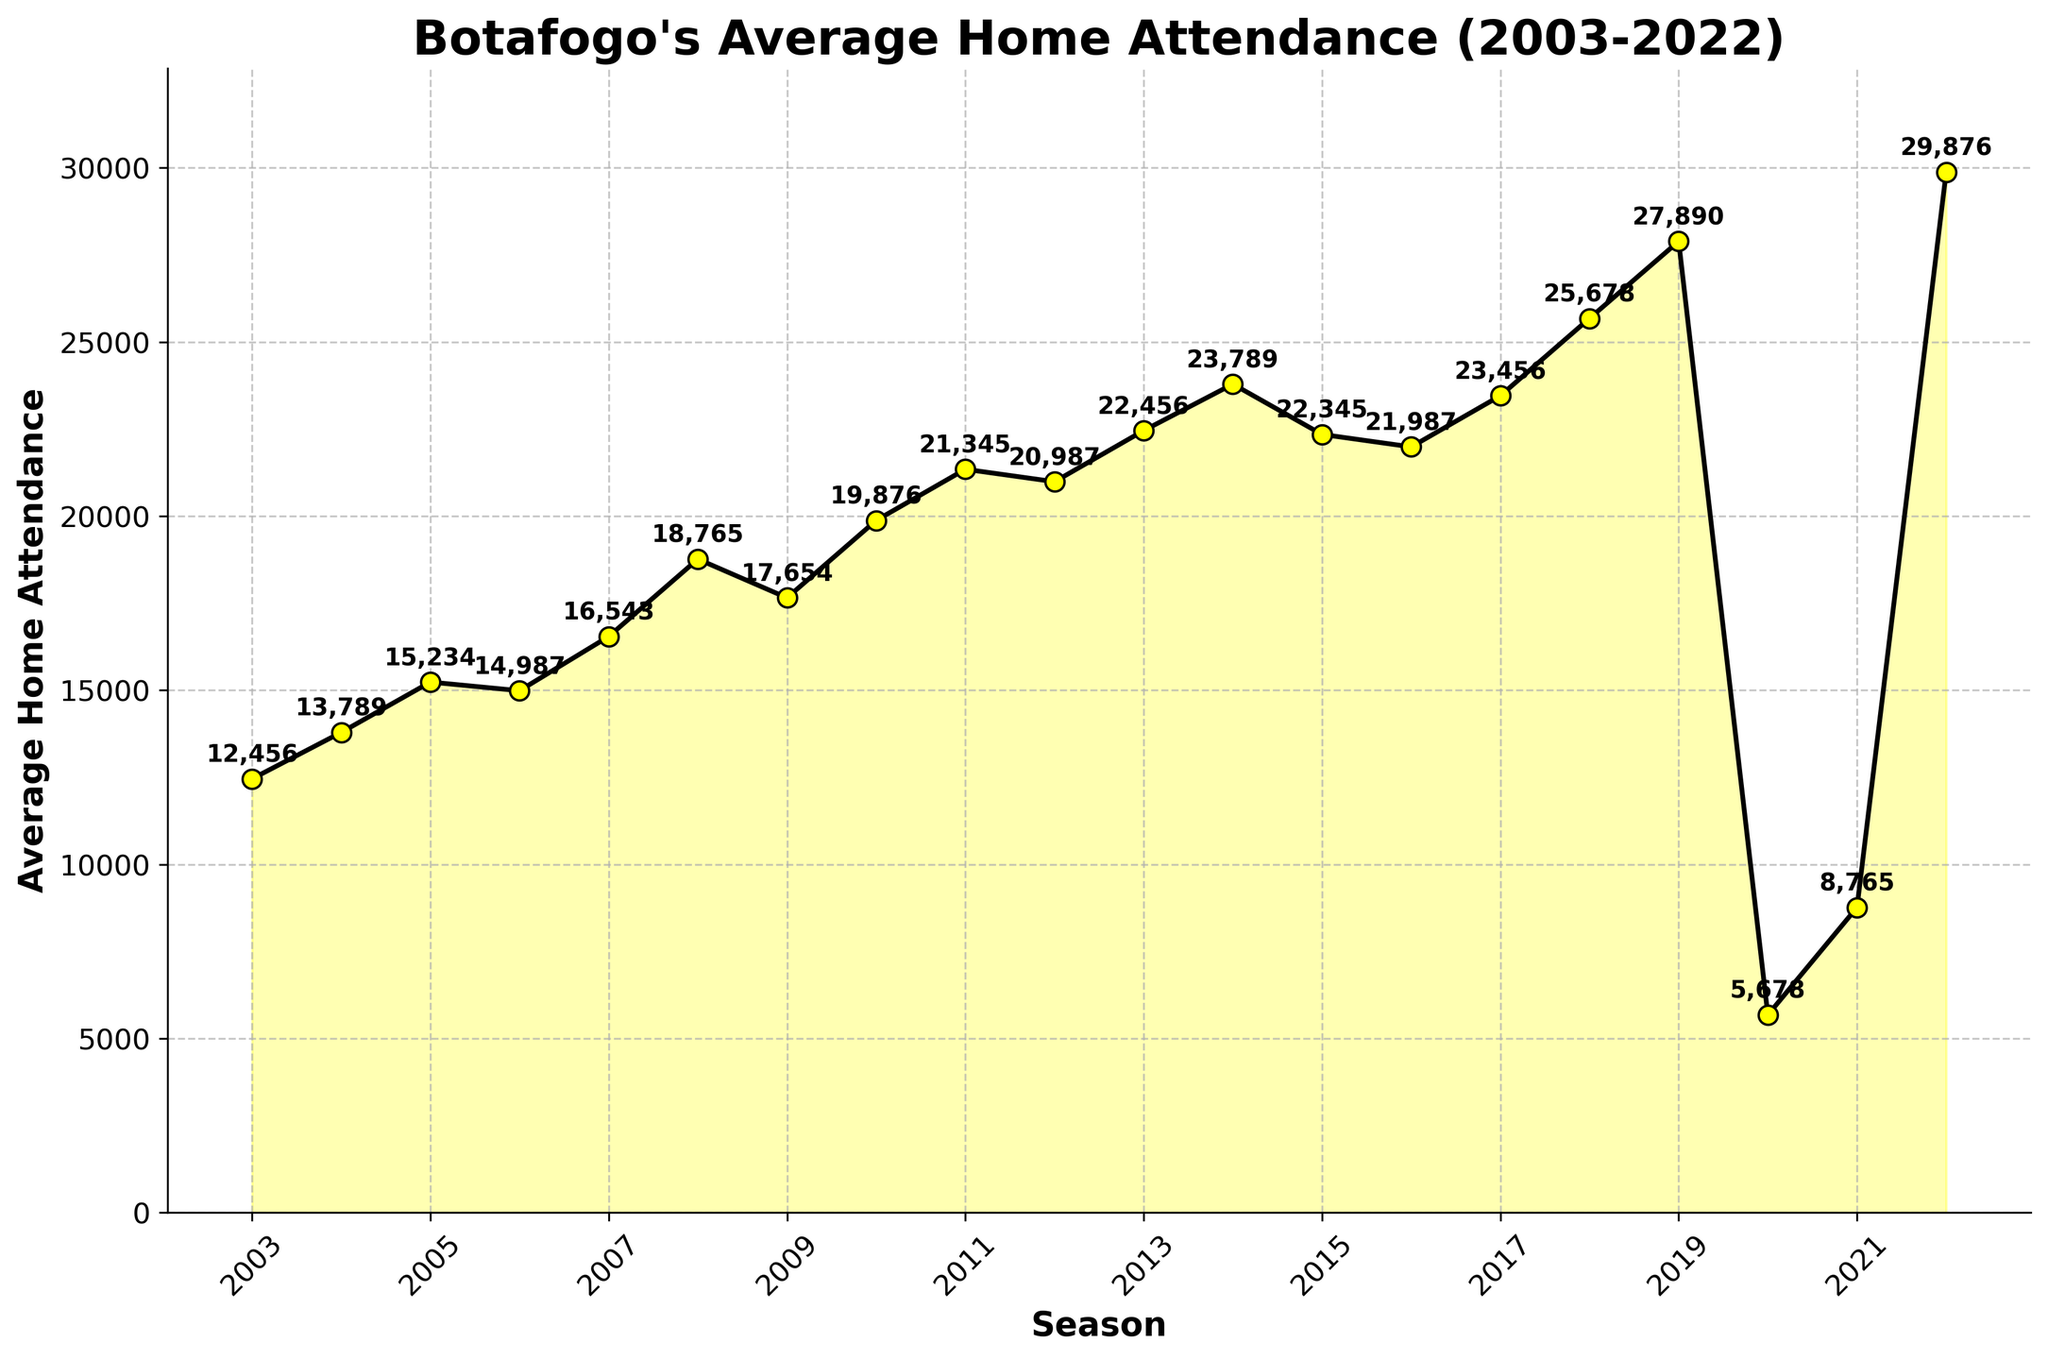Which season had the highest average home attendance? The highest point on the figure is the end of the line representing the 2022 season. By looking at the plot, the 2022 season has the highest value.
Answer: 2022 How did the average attendance change between 2010 and 2011? Comparing the points for 2010 and 2011 shows that the average home attendance increased from 19,876 to 21,345.
Answer: Increased What was the average home attendance in 2020, and how does it compare to 2021? The average home attendance in 2020 was 5,678, and in 2021 it increased to 8,765.
Answer: Increased What is the difference in average home attendance between the highest and the lowest seasons? The highest average home attendance was in 2022 with 29,876, and the lowest was in 2020 with 5,678. Calculating the difference gives 29,876 - 5,678.
Answer: 24,198 In which season did Botafogo see a significant drop in average home attendance? Observing the plot, there is a significant drop in attendance between 2019 and 2020 when the attendance fell from 27,890 to 5,678.
Answer: 2019 to 2020 What is the average home attendance from 2008 to 2010? The average home attendance for the seasons 2008, 2009, and 2010 are 18,765, 17,654, and 19,876 respectively. The sum of these values is 18,765 + 17,654 + 19,876 = 56,295. Dividing by the number of seasons (3) gives 56,295 / 3.
Answer: 18,765 Which was higher, the average home attendance in 2004 or 2005? Comparing the points for the seasons 2004 and 2005, 2005 has a higher attendance with 15,234 compared to 13,789 in 2004.
Answer: 2005 What visual trend do you observe from 2017 to 2019? There is an increasing trend in the average home attendance from 2017 (23,456) to 2019 (27,890). The line goes upward in this interval.
Answer: Increasing In how many seasons was the average home attendance above 20,000? By counting the seasons where the average home attendance is above the 20,000 mark, you find there are 8 such seasons (2010, 2011, 2012, 2013, 2014, 2017, 2018, 2019, and 2022).
Answer: 9 seasons Was the average home attendance in 2015 above or below 22,000? The point for 2015 on the line chart indicates an attendance of 22,345 which is above 22,000.
Answer: Above 